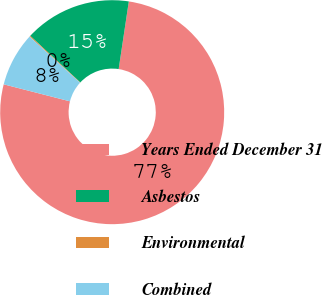Convert chart. <chart><loc_0><loc_0><loc_500><loc_500><pie_chart><fcel>Years Ended December 31<fcel>Asbestos<fcel>Environmental<fcel>Combined<nl><fcel>76.63%<fcel>15.44%<fcel>0.14%<fcel>7.79%<nl></chart> 